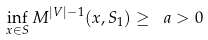Convert formula to latex. <formula><loc_0><loc_0><loc_500><loc_500>\inf _ { x \in S } M ^ { | V | - 1 } ( x , S _ { 1 } ) \geq \ a > 0</formula> 